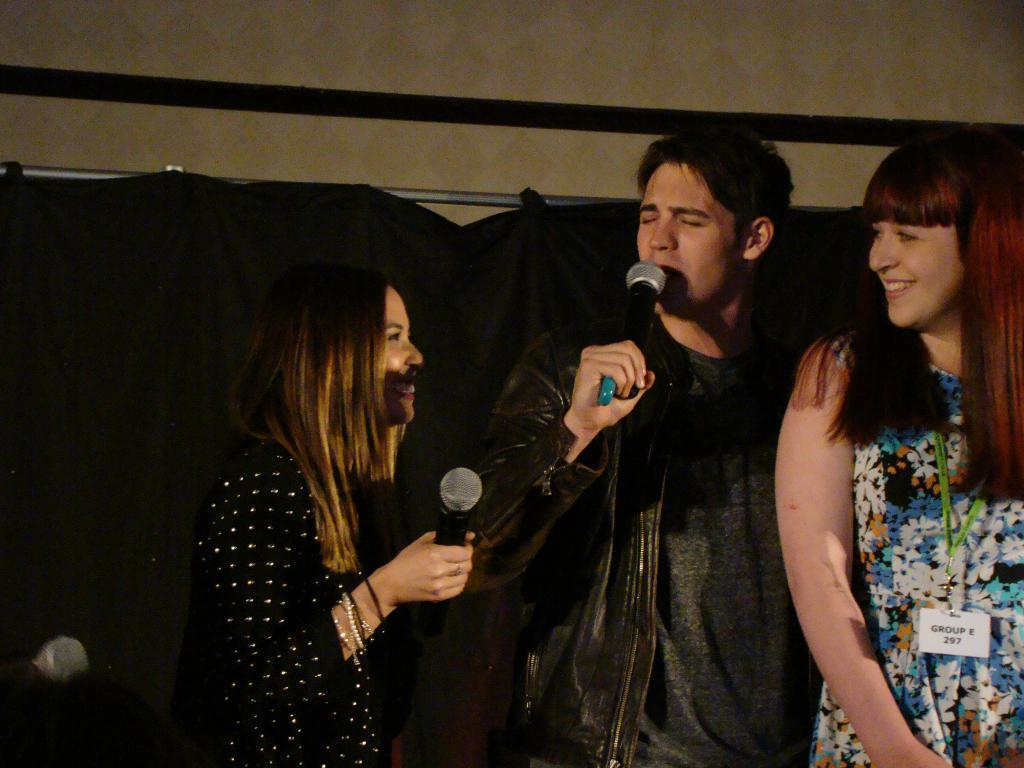How many people are present in the image? There are three people standing in the image. What are two of the people doing in the image? Two people are speaking with the help of a microphone. What type of volleyball game is being played in the image? There is no volleyball game present in the image. What ring is visible in the image? There is no ring visible in the image. 